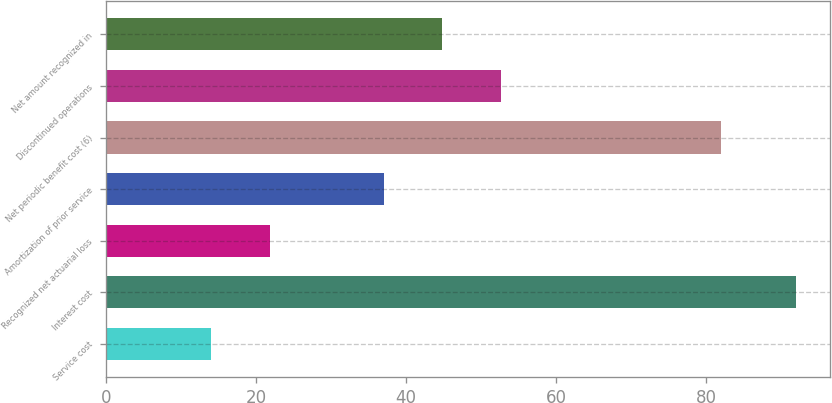Convert chart. <chart><loc_0><loc_0><loc_500><loc_500><bar_chart><fcel>Service cost<fcel>Interest cost<fcel>Recognized net actuarial loss<fcel>Amortization of prior service<fcel>Net periodic benefit cost (6)<fcel>Discontinued operations<fcel>Net amount recognized in<nl><fcel>14<fcel>92<fcel>21.8<fcel>37<fcel>82<fcel>52.6<fcel>44.8<nl></chart> 